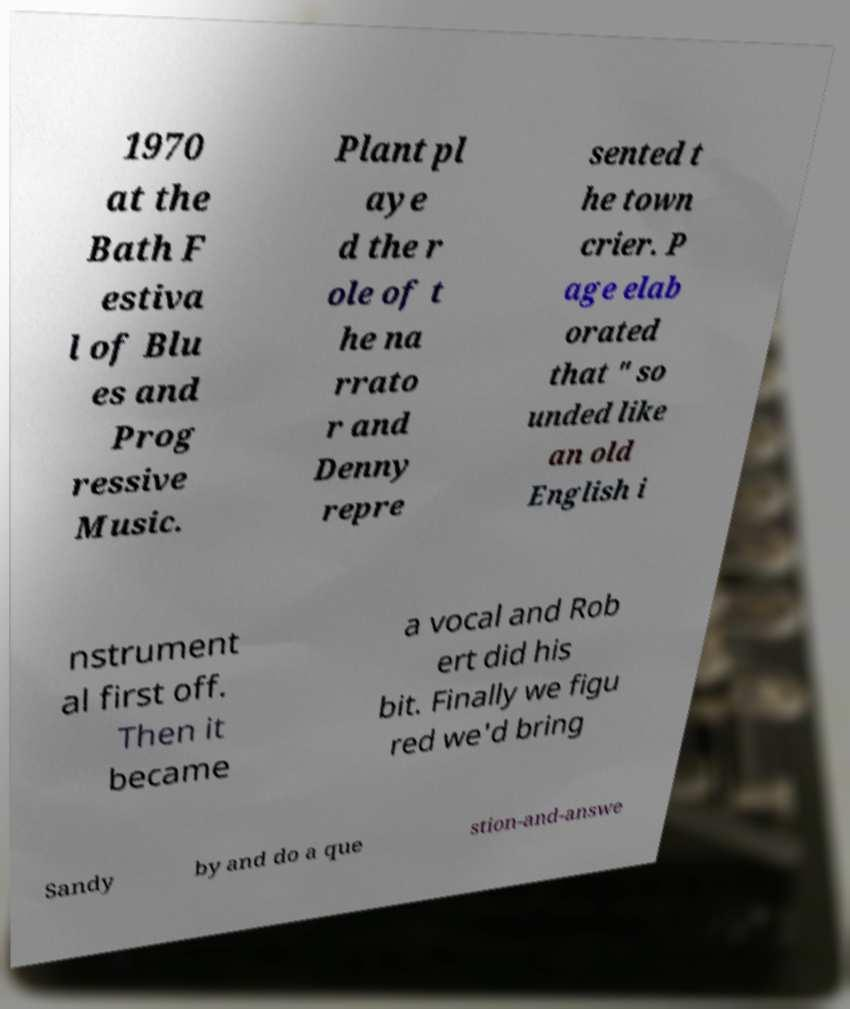Can you accurately transcribe the text from the provided image for me? 1970 at the Bath F estiva l of Blu es and Prog ressive Music. Plant pl aye d the r ole of t he na rrato r and Denny repre sented t he town crier. P age elab orated that " so unded like an old English i nstrument al first off. Then it became a vocal and Rob ert did his bit. Finally we figu red we'd bring Sandy by and do a que stion-and-answe 